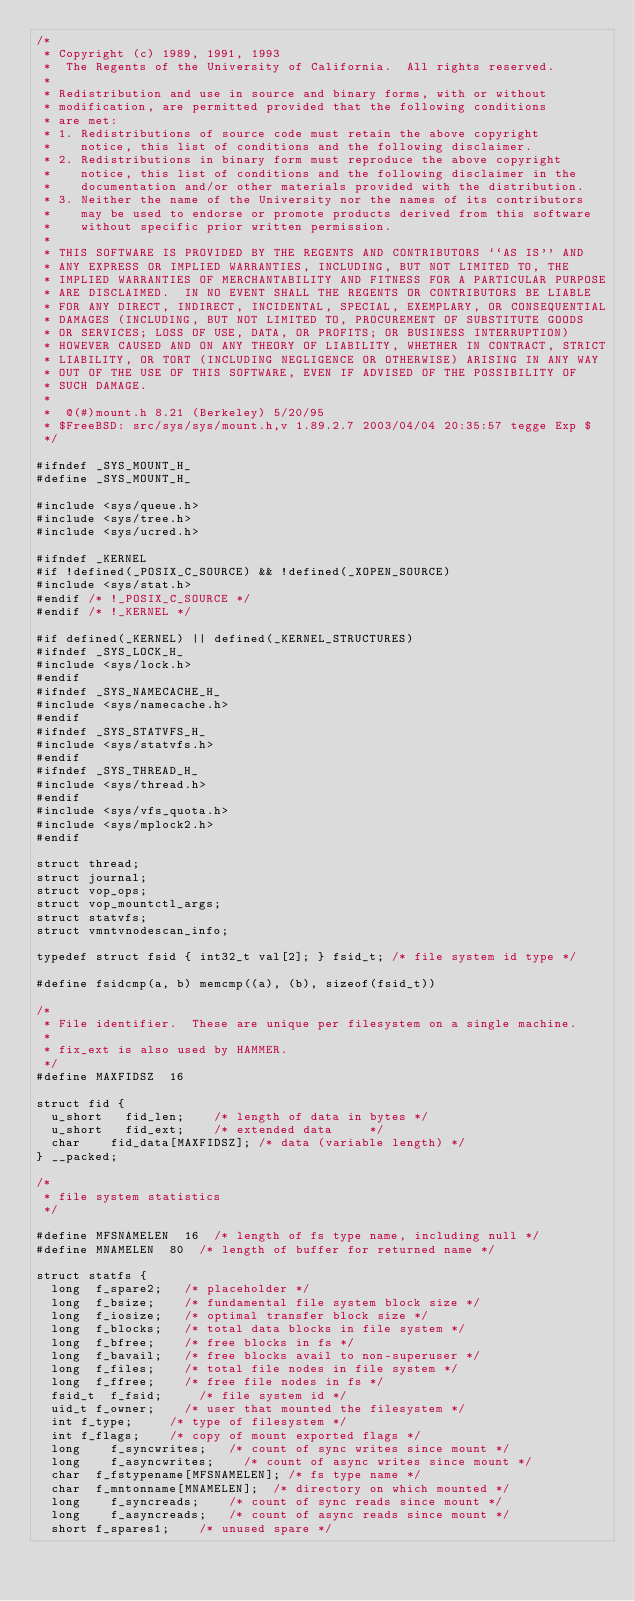Convert code to text. <code><loc_0><loc_0><loc_500><loc_500><_C_>/*
 * Copyright (c) 1989, 1991, 1993
 *	The Regents of the University of California.  All rights reserved.
 *
 * Redistribution and use in source and binary forms, with or without
 * modification, are permitted provided that the following conditions
 * are met:
 * 1. Redistributions of source code must retain the above copyright
 *    notice, this list of conditions and the following disclaimer.
 * 2. Redistributions in binary form must reproduce the above copyright
 *    notice, this list of conditions and the following disclaimer in the
 *    documentation and/or other materials provided with the distribution.
 * 3. Neither the name of the University nor the names of its contributors
 *    may be used to endorse or promote products derived from this software
 *    without specific prior written permission.
 *
 * THIS SOFTWARE IS PROVIDED BY THE REGENTS AND CONTRIBUTORS ``AS IS'' AND
 * ANY EXPRESS OR IMPLIED WARRANTIES, INCLUDING, BUT NOT LIMITED TO, THE
 * IMPLIED WARRANTIES OF MERCHANTABILITY AND FITNESS FOR A PARTICULAR PURPOSE
 * ARE DISCLAIMED.  IN NO EVENT SHALL THE REGENTS OR CONTRIBUTORS BE LIABLE
 * FOR ANY DIRECT, INDIRECT, INCIDENTAL, SPECIAL, EXEMPLARY, OR CONSEQUENTIAL
 * DAMAGES (INCLUDING, BUT NOT LIMITED TO, PROCUREMENT OF SUBSTITUTE GOODS
 * OR SERVICES; LOSS OF USE, DATA, OR PROFITS; OR BUSINESS INTERRUPTION)
 * HOWEVER CAUSED AND ON ANY THEORY OF LIABILITY, WHETHER IN CONTRACT, STRICT
 * LIABILITY, OR TORT (INCLUDING NEGLIGENCE OR OTHERWISE) ARISING IN ANY WAY
 * OUT OF THE USE OF THIS SOFTWARE, EVEN IF ADVISED OF THE POSSIBILITY OF
 * SUCH DAMAGE.
 *
 *	@(#)mount.h	8.21 (Berkeley) 5/20/95
 * $FreeBSD: src/sys/sys/mount.h,v 1.89.2.7 2003/04/04 20:35:57 tegge Exp $
 */

#ifndef _SYS_MOUNT_H_
#define _SYS_MOUNT_H_

#include <sys/queue.h>
#include <sys/tree.h>
#include <sys/ucred.h>

#ifndef _KERNEL
#if !defined(_POSIX_C_SOURCE) && !defined(_XOPEN_SOURCE)
#include <sys/stat.h>
#endif /* !_POSIX_C_SOURCE */
#endif /* !_KERNEL */

#if defined(_KERNEL) || defined(_KERNEL_STRUCTURES)
#ifndef _SYS_LOCK_H_
#include <sys/lock.h>
#endif
#ifndef _SYS_NAMECACHE_H_
#include <sys/namecache.h>
#endif
#ifndef _SYS_STATVFS_H_
#include <sys/statvfs.h>
#endif
#ifndef _SYS_THREAD_H_
#include <sys/thread.h>
#endif
#include <sys/vfs_quota.h>
#include <sys/mplock2.h>
#endif

struct thread;
struct journal;
struct vop_ops;
struct vop_mountctl_args;
struct statvfs;
struct vmntvnodescan_info;

typedef struct fsid { int32_t val[2]; } fsid_t;	/* file system id type */

#define fsidcmp(a, b) memcmp((a), (b), sizeof(fsid_t))

/*
 * File identifier.  These are unique per filesystem on a single machine.
 *
 * fix_ext is also used by HAMMER.
 */
#define	MAXFIDSZ	16

struct fid {
	u_short		fid_len;		/* length of data in bytes */
	u_short		fid_ext;		/* extended data 	   */
	char		fid_data[MAXFIDSZ];	/* data (variable length) */
} __packed;

/*
 * file system statistics
 */

#define MFSNAMELEN	16	/* length of fs type name, including null */
#define	MNAMELEN	80	/* length of buffer for returned name */

struct statfs {
	long	f_spare2;		/* placeholder */
	long	f_bsize;		/* fundamental file system block size */
	long	f_iosize;		/* optimal transfer block size */
	long	f_blocks;		/* total data blocks in file system */
	long	f_bfree;		/* free blocks in fs */
	long	f_bavail;		/* free blocks avail to non-superuser */
	long	f_files;		/* total file nodes in file system */
	long	f_ffree;		/* free file nodes in fs */
	fsid_t	f_fsid;			/* file system id */
	uid_t	f_owner;		/* user that mounted the filesystem */
	int	f_type;			/* type of filesystem */
	int	f_flags;		/* copy of mount exported flags */
	long    f_syncwrites;		/* count of sync writes since mount */
	long    f_asyncwrites;		/* count of async writes since mount */
	char	f_fstypename[MFSNAMELEN]; /* fs type name */
	char	f_mntonname[MNAMELEN];	/* directory on which mounted */
	long    f_syncreads;		/* count of sync reads since mount */
	long    f_asyncreads;		/* count of async reads since mount */
	short	f_spares1;		/* unused spare */</code> 